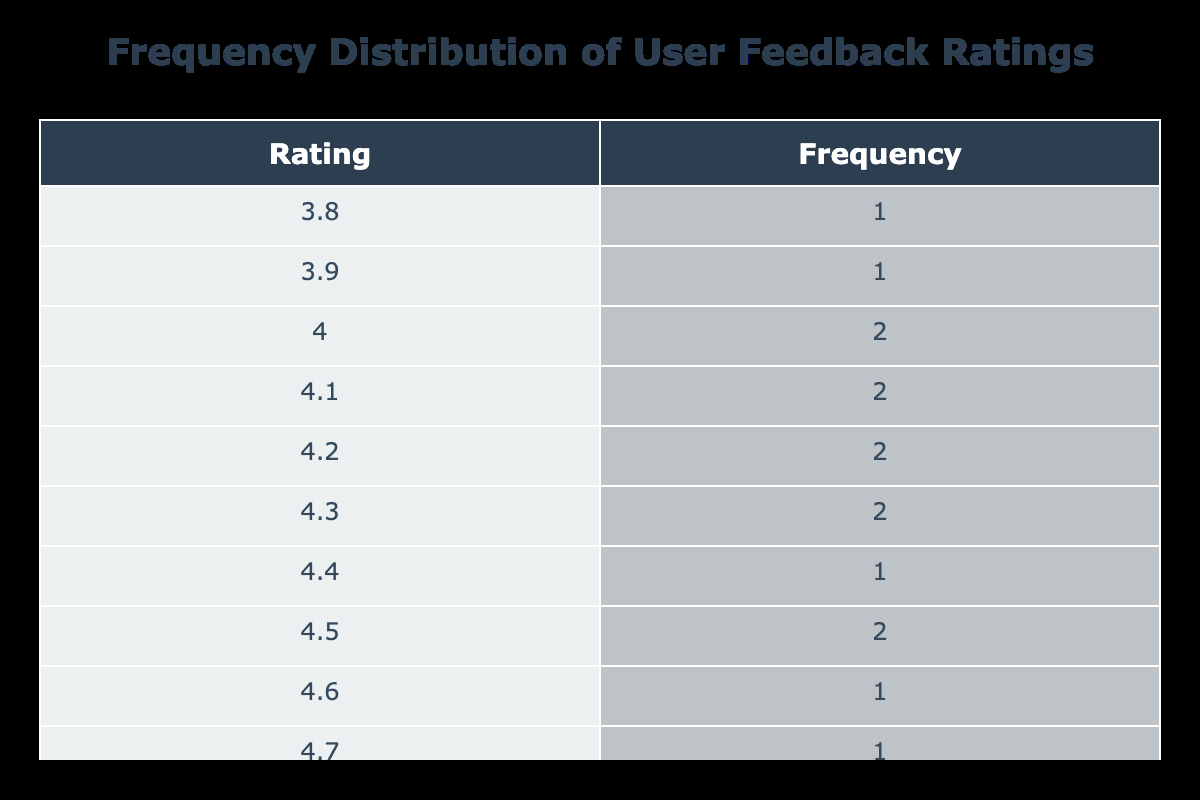What feature received the lowest user feedback rating? The table lists the user feedback ratings for various app features. By comparing the ratings, 'Video Tutorials' has the lowest rating at 3.8.
Answer: Video Tutorials Which feature has the highest user feedback rating? From the table, the highest rating is for 'Personalized Goals' at a score of 4.7.
Answer: Personalized Goals What is the average user feedback rating for the features associated with a rating of 4.1? The two features with a rating of 4.1 are 'Nicotine Level Tracker' and 'Weekly Challenges'. Adding these gives 4.1 + 4.1 = 8.2. Dividing by the number of features (2) gives an average of 4.1.
Answer: 4.1 Is there a feature that has a user feedback rating of 4.4? Yes, 'Habit Reminders' has a feedback rating of 4.4.
Answer: Yes What is the total frequency of features rated 4.0 and below? The ratings of 4.0 and below are 'Video Tutorials' (3.8), 'Integration with Wearable Devices' (3.9), totaling 2 features. Since the table lists the frequency only for unique ratings, no features share the same frequency.
Answer: 2 What are the features that received a rating above 4.2? The features with ratings above 4.2 according to the table are 'Personalized Goals' (4.7), 'Gamification Elements' (4.6), 'Daily Progress Tracking' (4.5), and 'Live Chat Support' (4.5), 'Success Stories' (4.3), 'Customizable Notifications' (4.3), and 'Habit Reminders' (4.4).
Answer: 7 What rating is more common among the features, 4.0 or 4.1? The frequency of rating 4.0 corresponds to two features ('Community Support Forums', 'Health Progress Graphs'), and the frequency for 4.1 corresponds to two features as well ('Nicotine Level Tracker', 'Weekly Challenges'). Therefore, they are equally common.
Answer: Equal Which category has more features: those rated above 4.2 or those rated below 4.2? Features rated above 4.2 include 'Personalized Goals', 'Gamification Elements', 'Daily Progress Tracking', 'Live Chat Support', 'Success Stories', 'Customizable Notifications', and 'Habit Reminders', totaling 7 features. Features rated below 4.2 include 'Video Tutorials', 'Integration with Wearable Devices', and 'Community Support Forums', totaling 3 features. Thus, features rated above 4.2 are more common.
Answer: Above 4.2 What percentage of features have a rating of 4.5 or higher? The features rated at 4.5 or higher are 'Personalized Goals', 'Gamification Elements', 'Daily Progress Tracking', 'Live Chat Support', 'Success Stories', and 'Habit Reminders', totaling 6 out of 15 features. Calculating gives 6/15 = 0.4 or 40%.
Answer: 40% 